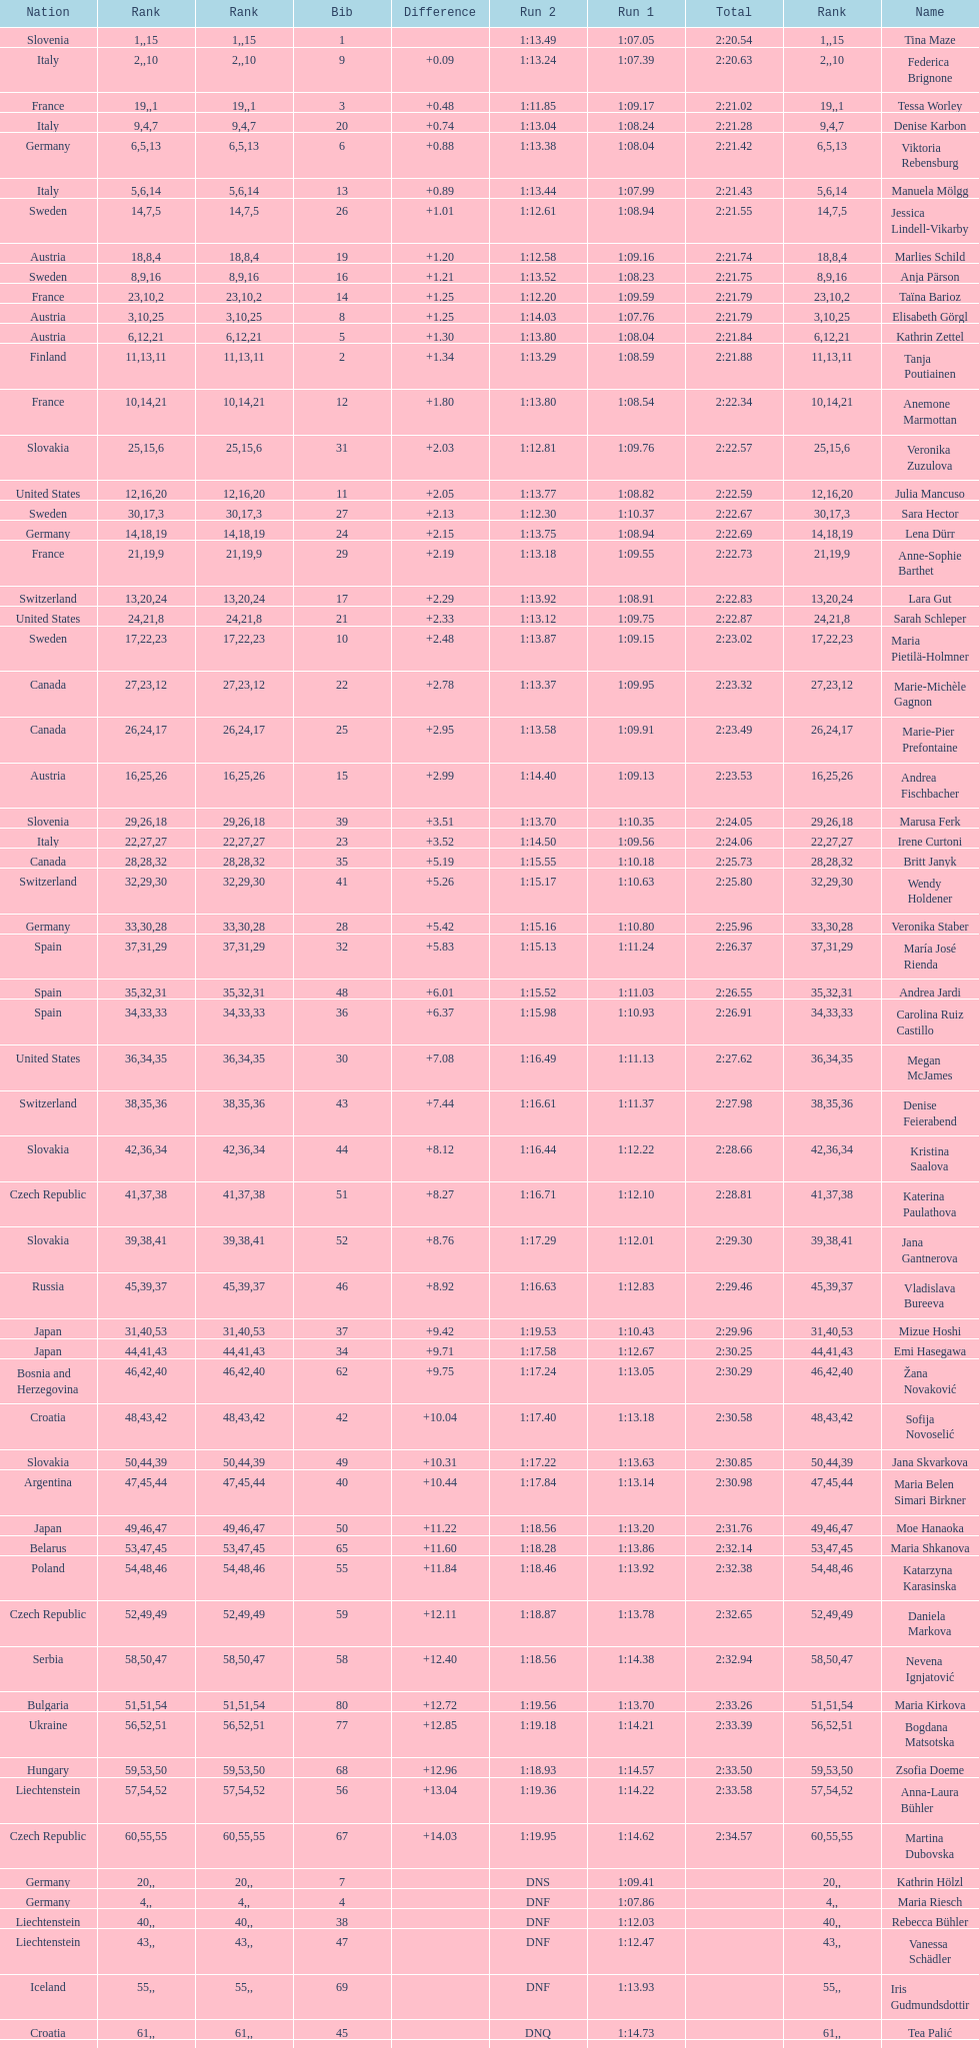What is the name before anja parson? Marlies Schild. 